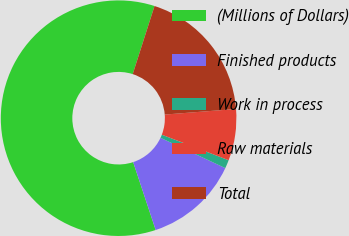Convert chart. <chart><loc_0><loc_0><loc_500><loc_500><pie_chart><fcel>(Millions of Dollars)<fcel>Finished products<fcel>Work in process<fcel>Raw materials<fcel>Total<nl><fcel>60.03%<fcel>12.94%<fcel>1.16%<fcel>7.05%<fcel>18.82%<nl></chart> 